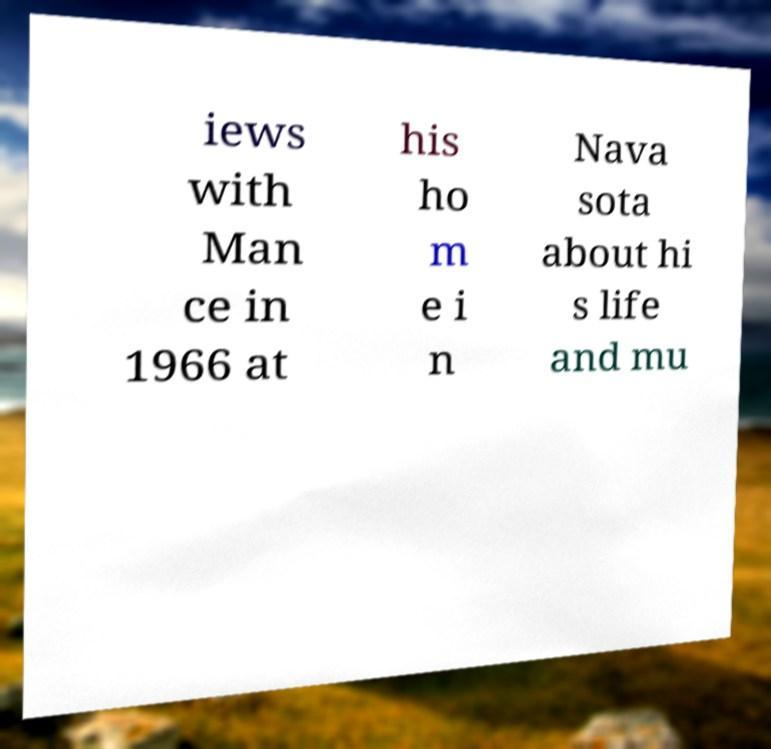Could you extract and type out the text from this image? iews with Man ce in 1966 at his ho m e i n Nava sota about hi s life and mu 